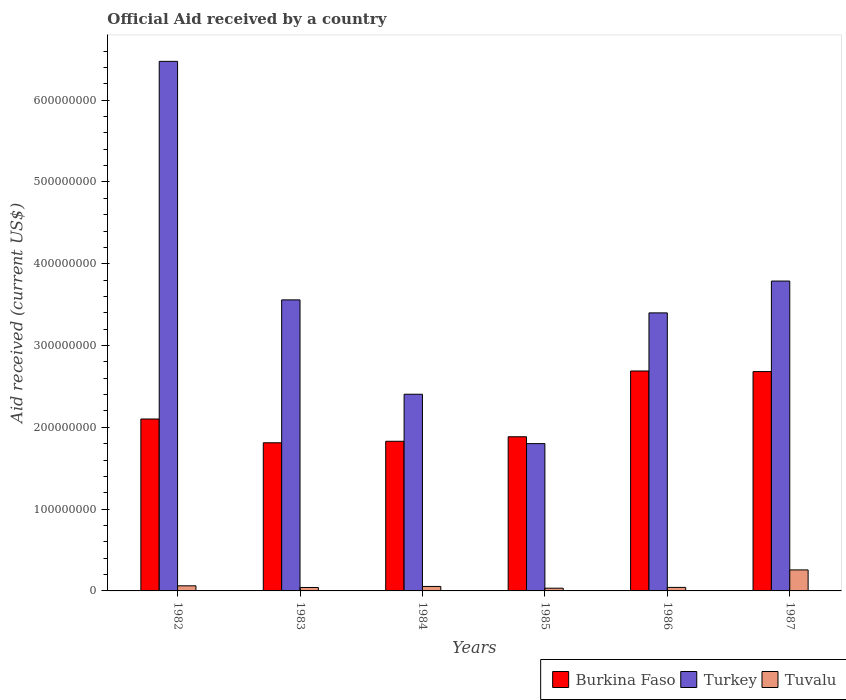How many groups of bars are there?
Offer a terse response. 6. Are the number of bars per tick equal to the number of legend labels?
Ensure brevity in your answer.  Yes. Are the number of bars on each tick of the X-axis equal?
Keep it short and to the point. Yes. How many bars are there on the 6th tick from the left?
Offer a very short reply. 3. How many bars are there on the 6th tick from the right?
Your response must be concise. 3. In how many cases, is the number of bars for a given year not equal to the number of legend labels?
Ensure brevity in your answer.  0. What is the net official aid received in Turkey in 1985?
Provide a succinct answer. 1.80e+08. Across all years, what is the maximum net official aid received in Burkina Faso?
Your answer should be compact. 2.69e+08. Across all years, what is the minimum net official aid received in Turkey?
Ensure brevity in your answer.  1.80e+08. In which year was the net official aid received in Turkey maximum?
Offer a very short reply. 1982. In which year was the net official aid received in Burkina Faso minimum?
Provide a short and direct response. 1983. What is the total net official aid received in Burkina Faso in the graph?
Your answer should be compact. 1.30e+09. What is the difference between the net official aid received in Tuvalu in 1984 and that in 1986?
Offer a very short reply. 1.17e+06. What is the difference between the net official aid received in Burkina Faso in 1982 and the net official aid received in Turkey in 1984?
Your answer should be very brief. -3.03e+07. What is the average net official aid received in Burkina Faso per year?
Provide a succinct answer. 2.17e+08. In the year 1982, what is the difference between the net official aid received in Turkey and net official aid received in Burkina Faso?
Ensure brevity in your answer.  4.37e+08. What is the ratio of the net official aid received in Turkey in 1982 to that in 1985?
Provide a short and direct response. 3.6. Is the difference between the net official aid received in Turkey in 1982 and 1986 greater than the difference between the net official aid received in Burkina Faso in 1982 and 1986?
Keep it short and to the point. Yes. What is the difference between the highest and the second highest net official aid received in Tuvalu?
Give a very brief answer. 1.94e+07. What is the difference between the highest and the lowest net official aid received in Tuvalu?
Ensure brevity in your answer.  2.24e+07. What does the 1st bar from the right in 1984 represents?
Ensure brevity in your answer.  Tuvalu. Is it the case that in every year, the sum of the net official aid received in Burkina Faso and net official aid received in Tuvalu is greater than the net official aid received in Turkey?
Your response must be concise. No. How many years are there in the graph?
Ensure brevity in your answer.  6. Are the values on the major ticks of Y-axis written in scientific E-notation?
Give a very brief answer. No. How many legend labels are there?
Your answer should be very brief. 3. What is the title of the graph?
Provide a short and direct response. Official Aid received by a country. What is the label or title of the Y-axis?
Provide a succinct answer. Aid received (current US$). What is the Aid received (current US$) of Burkina Faso in 1982?
Offer a terse response. 2.10e+08. What is the Aid received (current US$) in Turkey in 1982?
Offer a terse response. 6.48e+08. What is the Aid received (current US$) of Tuvalu in 1982?
Offer a terse response. 6.23e+06. What is the Aid received (current US$) in Burkina Faso in 1983?
Keep it short and to the point. 1.81e+08. What is the Aid received (current US$) of Turkey in 1983?
Provide a short and direct response. 3.56e+08. What is the Aid received (current US$) in Tuvalu in 1983?
Offer a terse response. 4.21e+06. What is the Aid received (current US$) of Burkina Faso in 1984?
Provide a succinct answer. 1.83e+08. What is the Aid received (current US$) in Turkey in 1984?
Keep it short and to the point. 2.40e+08. What is the Aid received (current US$) in Tuvalu in 1984?
Offer a very short reply. 5.47e+06. What is the Aid received (current US$) in Burkina Faso in 1985?
Your answer should be very brief. 1.88e+08. What is the Aid received (current US$) in Turkey in 1985?
Your answer should be compact. 1.80e+08. What is the Aid received (current US$) in Tuvalu in 1985?
Provide a short and direct response. 3.33e+06. What is the Aid received (current US$) of Burkina Faso in 1986?
Make the answer very short. 2.69e+08. What is the Aid received (current US$) of Turkey in 1986?
Your answer should be very brief. 3.40e+08. What is the Aid received (current US$) of Tuvalu in 1986?
Provide a short and direct response. 4.30e+06. What is the Aid received (current US$) in Burkina Faso in 1987?
Your answer should be very brief. 2.68e+08. What is the Aid received (current US$) in Turkey in 1987?
Your response must be concise. 3.79e+08. What is the Aid received (current US$) of Tuvalu in 1987?
Your answer should be compact. 2.57e+07. Across all years, what is the maximum Aid received (current US$) in Burkina Faso?
Provide a short and direct response. 2.69e+08. Across all years, what is the maximum Aid received (current US$) of Turkey?
Your answer should be very brief. 6.48e+08. Across all years, what is the maximum Aid received (current US$) of Tuvalu?
Your answer should be very brief. 2.57e+07. Across all years, what is the minimum Aid received (current US$) in Burkina Faso?
Provide a short and direct response. 1.81e+08. Across all years, what is the minimum Aid received (current US$) in Turkey?
Give a very brief answer. 1.80e+08. Across all years, what is the minimum Aid received (current US$) of Tuvalu?
Make the answer very short. 3.33e+06. What is the total Aid received (current US$) of Burkina Faso in the graph?
Your response must be concise. 1.30e+09. What is the total Aid received (current US$) in Turkey in the graph?
Offer a terse response. 2.14e+09. What is the total Aid received (current US$) of Tuvalu in the graph?
Your response must be concise. 4.92e+07. What is the difference between the Aid received (current US$) of Burkina Faso in 1982 and that in 1983?
Keep it short and to the point. 2.90e+07. What is the difference between the Aid received (current US$) in Turkey in 1982 and that in 1983?
Your response must be concise. 2.92e+08. What is the difference between the Aid received (current US$) in Tuvalu in 1982 and that in 1983?
Provide a short and direct response. 2.02e+06. What is the difference between the Aid received (current US$) of Burkina Faso in 1982 and that in 1984?
Provide a short and direct response. 2.72e+07. What is the difference between the Aid received (current US$) of Turkey in 1982 and that in 1984?
Give a very brief answer. 4.07e+08. What is the difference between the Aid received (current US$) in Tuvalu in 1982 and that in 1984?
Provide a succinct answer. 7.60e+05. What is the difference between the Aid received (current US$) in Burkina Faso in 1982 and that in 1985?
Keep it short and to the point. 2.17e+07. What is the difference between the Aid received (current US$) in Turkey in 1982 and that in 1985?
Make the answer very short. 4.67e+08. What is the difference between the Aid received (current US$) of Tuvalu in 1982 and that in 1985?
Keep it short and to the point. 2.90e+06. What is the difference between the Aid received (current US$) in Burkina Faso in 1982 and that in 1986?
Your answer should be compact. -5.87e+07. What is the difference between the Aid received (current US$) of Turkey in 1982 and that in 1986?
Your response must be concise. 3.08e+08. What is the difference between the Aid received (current US$) of Tuvalu in 1982 and that in 1986?
Ensure brevity in your answer.  1.93e+06. What is the difference between the Aid received (current US$) of Burkina Faso in 1982 and that in 1987?
Your answer should be compact. -5.80e+07. What is the difference between the Aid received (current US$) in Turkey in 1982 and that in 1987?
Your answer should be compact. 2.69e+08. What is the difference between the Aid received (current US$) in Tuvalu in 1982 and that in 1987?
Provide a short and direct response. -1.94e+07. What is the difference between the Aid received (current US$) of Burkina Faso in 1983 and that in 1984?
Your answer should be very brief. -1.84e+06. What is the difference between the Aid received (current US$) in Turkey in 1983 and that in 1984?
Make the answer very short. 1.15e+08. What is the difference between the Aid received (current US$) of Tuvalu in 1983 and that in 1984?
Give a very brief answer. -1.26e+06. What is the difference between the Aid received (current US$) in Burkina Faso in 1983 and that in 1985?
Offer a terse response. -7.35e+06. What is the difference between the Aid received (current US$) of Turkey in 1983 and that in 1985?
Keep it short and to the point. 1.76e+08. What is the difference between the Aid received (current US$) of Tuvalu in 1983 and that in 1985?
Ensure brevity in your answer.  8.80e+05. What is the difference between the Aid received (current US$) of Burkina Faso in 1983 and that in 1986?
Your response must be concise. -8.78e+07. What is the difference between the Aid received (current US$) of Turkey in 1983 and that in 1986?
Your response must be concise. 1.59e+07. What is the difference between the Aid received (current US$) in Tuvalu in 1983 and that in 1986?
Make the answer very short. -9.00e+04. What is the difference between the Aid received (current US$) of Burkina Faso in 1983 and that in 1987?
Give a very brief answer. -8.70e+07. What is the difference between the Aid received (current US$) in Turkey in 1983 and that in 1987?
Keep it short and to the point. -2.30e+07. What is the difference between the Aid received (current US$) of Tuvalu in 1983 and that in 1987?
Your answer should be compact. -2.15e+07. What is the difference between the Aid received (current US$) of Burkina Faso in 1984 and that in 1985?
Offer a terse response. -5.51e+06. What is the difference between the Aid received (current US$) in Turkey in 1984 and that in 1985?
Offer a terse response. 6.04e+07. What is the difference between the Aid received (current US$) in Tuvalu in 1984 and that in 1985?
Offer a very short reply. 2.14e+06. What is the difference between the Aid received (current US$) in Burkina Faso in 1984 and that in 1986?
Provide a short and direct response. -8.59e+07. What is the difference between the Aid received (current US$) in Turkey in 1984 and that in 1986?
Offer a terse response. -9.95e+07. What is the difference between the Aid received (current US$) of Tuvalu in 1984 and that in 1986?
Provide a short and direct response. 1.17e+06. What is the difference between the Aid received (current US$) of Burkina Faso in 1984 and that in 1987?
Offer a very short reply. -8.52e+07. What is the difference between the Aid received (current US$) in Turkey in 1984 and that in 1987?
Provide a short and direct response. -1.38e+08. What is the difference between the Aid received (current US$) in Tuvalu in 1984 and that in 1987?
Make the answer very short. -2.02e+07. What is the difference between the Aid received (current US$) in Burkina Faso in 1985 and that in 1986?
Offer a very short reply. -8.04e+07. What is the difference between the Aid received (current US$) of Turkey in 1985 and that in 1986?
Give a very brief answer. -1.60e+08. What is the difference between the Aid received (current US$) of Tuvalu in 1985 and that in 1986?
Ensure brevity in your answer.  -9.70e+05. What is the difference between the Aid received (current US$) in Burkina Faso in 1985 and that in 1987?
Your response must be concise. -7.97e+07. What is the difference between the Aid received (current US$) in Turkey in 1985 and that in 1987?
Your response must be concise. -1.99e+08. What is the difference between the Aid received (current US$) in Tuvalu in 1985 and that in 1987?
Your response must be concise. -2.24e+07. What is the difference between the Aid received (current US$) of Burkina Faso in 1986 and that in 1987?
Offer a very short reply. 7.30e+05. What is the difference between the Aid received (current US$) in Turkey in 1986 and that in 1987?
Provide a short and direct response. -3.89e+07. What is the difference between the Aid received (current US$) in Tuvalu in 1986 and that in 1987?
Your response must be concise. -2.14e+07. What is the difference between the Aid received (current US$) in Burkina Faso in 1982 and the Aid received (current US$) in Turkey in 1983?
Make the answer very short. -1.46e+08. What is the difference between the Aid received (current US$) of Burkina Faso in 1982 and the Aid received (current US$) of Tuvalu in 1983?
Provide a short and direct response. 2.06e+08. What is the difference between the Aid received (current US$) in Turkey in 1982 and the Aid received (current US$) in Tuvalu in 1983?
Provide a short and direct response. 6.43e+08. What is the difference between the Aid received (current US$) in Burkina Faso in 1982 and the Aid received (current US$) in Turkey in 1984?
Ensure brevity in your answer.  -3.03e+07. What is the difference between the Aid received (current US$) in Burkina Faso in 1982 and the Aid received (current US$) in Tuvalu in 1984?
Ensure brevity in your answer.  2.05e+08. What is the difference between the Aid received (current US$) in Turkey in 1982 and the Aid received (current US$) in Tuvalu in 1984?
Offer a very short reply. 6.42e+08. What is the difference between the Aid received (current US$) in Burkina Faso in 1982 and the Aid received (current US$) in Turkey in 1985?
Keep it short and to the point. 3.01e+07. What is the difference between the Aid received (current US$) of Burkina Faso in 1982 and the Aid received (current US$) of Tuvalu in 1985?
Your answer should be compact. 2.07e+08. What is the difference between the Aid received (current US$) of Turkey in 1982 and the Aid received (current US$) of Tuvalu in 1985?
Ensure brevity in your answer.  6.44e+08. What is the difference between the Aid received (current US$) in Burkina Faso in 1982 and the Aid received (current US$) in Turkey in 1986?
Keep it short and to the point. -1.30e+08. What is the difference between the Aid received (current US$) in Burkina Faso in 1982 and the Aid received (current US$) in Tuvalu in 1986?
Ensure brevity in your answer.  2.06e+08. What is the difference between the Aid received (current US$) of Turkey in 1982 and the Aid received (current US$) of Tuvalu in 1986?
Your response must be concise. 6.43e+08. What is the difference between the Aid received (current US$) in Burkina Faso in 1982 and the Aid received (current US$) in Turkey in 1987?
Your answer should be compact. -1.69e+08. What is the difference between the Aid received (current US$) in Burkina Faso in 1982 and the Aid received (current US$) in Tuvalu in 1987?
Provide a short and direct response. 1.85e+08. What is the difference between the Aid received (current US$) of Turkey in 1982 and the Aid received (current US$) of Tuvalu in 1987?
Keep it short and to the point. 6.22e+08. What is the difference between the Aid received (current US$) in Burkina Faso in 1983 and the Aid received (current US$) in Turkey in 1984?
Your response must be concise. -5.93e+07. What is the difference between the Aid received (current US$) in Burkina Faso in 1983 and the Aid received (current US$) in Tuvalu in 1984?
Give a very brief answer. 1.76e+08. What is the difference between the Aid received (current US$) in Turkey in 1983 and the Aid received (current US$) in Tuvalu in 1984?
Your answer should be compact. 3.50e+08. What is the difference between the Aid received (current US$) of Burkina Faso in 1983 and the Aid received (current US$) of Turkey in 1985?
Make the answer very short. 1.04e+06. What is the difference between the Aid received (current US$) in Burkina Faso in 1983 and the Aid received (current US$) in Tuvalu in 1985?
Make the answer very short. 1.78e+08. What is the difference between the Aid received (current US$) of Turkey in 1983 and the Aid received (current US$) of Tuvalu in 1985?
Your answer should be compact. 3.53e+08. What is the difference between the Aid received (current US$) of Burkina Faso in 1983 and the Aid received (current US$) of Turkey in 1986?
Give a very brief answer. -1.59e+08. What is the difference between the Aid received (current US$) of Burkina Faso in 1983 and the Aid received (current US$) of Tuvalu in 1986?
Make the answer very short. 1.77e+08. What is the difference between the Aid received (current US$) of Turkey in 1983 and the Aid received (current US$) of Tuvalu in 1986?
Make the answer very short. 3.52e+08. What is the difference between the Aid received (current US$) of Burkina Faso in 1983 and the Aid received (current US$) of Turkey in 1987?
Your answer should be compact. -1.98e+08. What is the difference between the Aid received (current US$) of Burkina Faso in 1983 and the Aid received (current US$) of Tuvalu in 1987?
Offer a very short reply. 1.55e+08. What is the difference between the Aid received (current US$) of Turkey in 1983 and the Aid received (current US$) of Tuvalu in 1987?
Offer a terse response. 3.30e+08. What is the difference between the Aid received (current US$) of Burkina Faso in 1984 and the Aid received (current US$) of Turkey in 1985?
Offer a very short reply. 2.88e+06. What is the difference between the Aid received (current US$) of Burkina Faso in 1984 and the Aid received (current US$) of Tuvalu in 1985?
Your response must be concise. 1.80e+08. What is the difference between the Aid received (current US$) in Turkey in 1984 and the Aid received (current US$) in Tuvalu in 1985?
Give a very brief answer. 2.37e+08. What is the difference between the Aid received (current US$) of Burkina Faso in 1984 and the Aid received (current US$) of Turkey in 1986?
Your answer should be compact. -1.57e+08. What is the difference between the Aid received (current US$) of Burkina Faso in 1984 and the Aid received (current US$) of Tuvalu in 1986?
Give a very brief answer. 1.79e+08. What is the difference between the Aid received (current US$) in Turkey in 1984 and the Aid received (current US$) in Tuvalu in 1986?
Your response must be concise. 2.36e+08. What is the difference between the Aid received (current US$) in Burkina Faso in 1984 and the Aid received (current US$) in Turkey in 1987?
Ensure brevity in your answer.  -1.96e+08. What is the difference between the Aid received (current US$) in Burkina Faso in 1984 and the Aid received (current US$) in Tuvalu in 1987?
Keep it short and to the point. 1.57e+08. What is the difference between the Aid received (current US$) in Turkey in 1984 and the Aid received (current US$) in Tuvalu in 1987?
Your answer should be compact. 2.15e+08. What is the difference between the Aid received (current US$) of Burkina Faso in 1985 and the Aid received (current US$) of Turkey in 1986?
Your answer should be very brief. -1.51e+08. What is the difference between the Aid received (current US$) of Burkina Faso in 1985 and the Aid received (current US$) of Tuvalu in 1986?
Offer a very short reply. 1.84e+08. What is the difference between the Aid received (current US$) of Turkey in 1985 and the Aid received (current US$) of Tuvalu in 1986?
Offer a terse response. 1.76e+08. What is the difference between the Aid received (current US$) in Burkina Faso in 1985 and the Aid received (current US$) in Turkey in 1987?
Give a very brief answer. -1.90e+08. What is the difference between the Aid received (current US$) in Burkina Faso in 1985 and the Aid received (current US$) in Tuvalu in 1987?
Make the answer very short. 1.63e+08. What is the difference between the Aid received (current US$) in Turkey in 1985 and the Aid received (current US$) in Tuvalu in 1987?
Offer a terse response. 1.54e+08. What is the difference between the Aid received (current US$) in Burkina Faso in 1986 and the Aid received (current US$) in Turkey in 1987?
Keep it short and to the point. -1.10e+08. What is the difference between the Aid received (current US$) of Burkina Faso in 1986 and the Aid received (current US$) of Tuvalu in 1987?
Keep it short and to the point. 2.43e+08. What is the difference between the Aid received (current US$) of Turkey in 1986 and the Aid received (current US$) of Tuvalu in 1987?
Give a very brief answer. 3.14e+08. What is the average Aid received (current US$) of Burkina Faso per year?
Provide a short and direct response. 2.17e+08. What is the average Aid received (current US$) in Turkey per year?
Keep it short and to the point. 3.57e+08. What is the average Aid received (current US$) of Tuvalu per year?
Provide a short and direct response. 8.20e+06. In the year 1982, what is the difference between the Aid received (current US$) of Burkina Faso and Aid received (current US$) of Turkey?
Give a very brief answer. -4.37e+08. In the year 1982, what is the difference between the Aid received (current US$) of Burkina Faso and Aid received (current US$) of Tuvalu?
Your answer should be very brief. 2.04e+08. In the year 1982, what is the difference between the Aid received (current US$) in Turkey and Aid received (current US$) in Tuvalu?
Offer a very short reply. 6.41e+08. In the year 1983, what is the difference between the Aid received (current US$) in Burkina Faso and Aid received (current US$) in Turkey?
Make the answer very short. -1.75e+08. In the year 1983, what is the difference between the Aid received (current US$) of Burkina Faso and Aid received (current US$) of Tuvalu?
Make the answer very short. 1.77e+08. In the year 1983, what is the difference between the Aid received (current US$) in Turkey and Aid received (current US$) in Tuvalu?
Offer a terse response. 3.52e+08. In the year 1984, what is the difference between the Aid received (current US$) of Burkina Faso and Aid received (current US$) of Turkey?
Your response must be concise. -5.75e+07. In the year 1984, what is the difference between the Aid received (current US$) of Burkina Faso and Aid received (current US$) of Tuvalu?
Offer a very short reply. 1.78e+08. In the year 1984, what is the difference between the Aid received (current US$) of Turkey and Aid received (current US$) of Tuvalu?
Provide a succinct answer. 2.35e+08. In the year 1985, what is the difference between the Aid received (current US$) in Burkina Faso and Aid received (current US$) in Turkey?
Your answer should be compact. 8.39e+06. In the year 1985, what is the difference between the Aid received (current US$) in Burkina Faso and Aid received (current US$) in Tuvalu?
Make the answer very short. 1.85e+08. In the year 1985, what is the difference between the Aid received (current US$) of Turkey and Aid received (current US$) of Tuvalu?
Your answer should be very brief. 1.77e+08. In the year 1986, what is the difference between the Aid received (current US$) of Burkina Faso and Aid received (current US$) of Turkey?
Your answer should be compact. -7.10e+07. In the year 1986, what is the difference between the Aid received (current US$) of Burkina Faso and Aid received (current US$) of Tuvalu?
Make the answer very short. 2.65e+08. In the year 1986, what is the difference between the Aid received (current US$) in Turkey and Aid received (current US$) in Tuvalu?
Your answer should be very brief. 3.36e+08. In the year 1987, what is the difference between the Aid received (current US$) of Burkina Faso and Aid received (current US$) of Turkey?
Ensure brevity in your answer.  -1.11e+08. In the year 1987, what is the difference between the Aid received (current US$) of Burkina Faso and Aid received (current US$) of Tuvalu?
Make the answer very short. 2.42e+08. In the year 1987, what is the difference between the Aid received (current US$) of Turkey and Aid received (current US$) of Tuvalu?
Make the answer very short. 3.53e+08. What is the ratio of the Aid received (current US$) of Burkina Faso in 1982 to that in 1983?
Make the answer very short. 1.16. What is the ratio of the Aid received (current US$) of Turkey in 1982 to that in 1983?
Give a very brief answer. 1.82. What is the ratio of the Aid received (current US$) in Tuvalu in 1982 to that in 1983?
Make the answer very short. 1.48. What is the ratio of the Aid received (current US$) of Burkina Faso in 1982 to that in 1984?
Make the answer very short. 1.15. What is the ratio of the Aid received (current US$) in Turkey in 1982 to that in 1984?
Provide a succinct answer. 2.69. What is the ratio of the Aid received (current US$) in Tuvalu in 1982 to that in 1984?
Your answer should be compact. 1.14. What is the ratio of the Aid received (current US$) in Burkina Faso in 1982 to that in 1985?
Keep it short and to the point. 1.12. What is the ratio of the Aid received (current US$) in Turkey in 1982 to that in 1985?
Ensure brevity in your answer.  3.6. What is the ratio of the Aid received (current US$) in Tuvalu in 1982 to that in 1985?
Your answer should be compact. 1.87. What is the ratio of the Aid received (current US$) of Burkina Faso in 1982 to that in 1986?
Give a very brief answer. 0.78. What is the ratio of the Aid received (current US$) of Turkey in 1982 to that in 1986?
Offer a terse response. 1.9. What is the ratio of the Aid received (current US$) in Tuvalu in 1982 to that in 1986?
Keep it short and to the point. 1.45. What is the ratio of the Aid received (current US$) in Burkina Faso in 1982 to that in 1987?
Ensure brevity in your answer.  0.78. What is the ratio of the Aid received (current US$) of Turkey in 1982 to that in 1987?
Your response must be concise. 1.71. What is the ratio of the Aid received (current US$) of Tuvalu in 1982 to that in 1987?
Your answer should be compact. 0.24. What is the ratio of the Aid received (current US$) in Turkey in 1983 to that in 1984?
Keep it short and to the point. 1.48. What is the ratio of the Aid received (current US$) of Tuvalu in 1983 to that in 1984?
Give a very brief answer. 0.77. What is the ratio of the Aid received (current US$) in Burkina Faso in 1983 to that in 1985?
Offer a terse response. 0.96. What is the ratio of the Aid received (current US$) in Turkey in 1983 to that in 1985?
Give a very brief answer. 1.98. What is the ratio of the Aid received (current US$) in Tuvalu in 1983 to that in 1985?
Ensure brevity in your answer.  1.26. What is the ratio of the Aid received (current US$) of Burkina Faso in 1983 to that in 1986?
Ensure brevity in your answer.  0.67. What is the ratio of the Aid received (current US$) in Turkey in 1983 to that in 1986?
Offer a very short reply. 1.05. What is the ratio of the Aid received (current US$) in Tuvalu in 1983 to that in 1986?
Your response must be concise. 0.98. What is the ratio of the Aid received (current US$) in Burkina Faso in 1983 to that in 1987?
Your answer should be very brief. 0.68. What is the ratio of the Aid received (current US$) in Turkey in 1983 to that in 1987?
Your answer should be compact. 0.94. What is the ratio of the Aid received (current US$) of Tuvalu in 1983 to that in 1987?
Offer a very short reply. 0.16. What is the ratio of the Aid received (current US$) in Burkina Faso in 1984 to that in 1985?
Your answer should be very brief. 0.97. What is the ratio of the Aid received (current US$) of Turkey in 1984 to that in 1985?
Keep it short and to the point. 1.34. What is the ratio of the Aid received (current US$) in Tuvalu in 1984 to that in 1985?
Provide a short and direct response. 1.64. What is the ratio of the Aid received (current US$) of Burkina Faso in 1984 to that in 1986?
Give a very brief answer. 0.68. What is the ratio of the Aid received (current US$) in Turkey in 1984 to that in 1986?
Provide a short and direct response. 0.71. What is the ratio of the Aid received (current US$) of Tuvalu in 1984 to that in 1986?
Your response must be concise. 1.27. What is the ratio of the Aid received (current US$) in Burkina Faso in 1984 to that in 1987?
Your answer should be very brief. 0.68. What is the ratio of the Aid received (current US$) in Turkey in 1984 to that in 1987?
Ensure brevity in your answer.  0.63. What is the ratio of the Aid received (current US$) in Tuvalu in 1984 to that in 1987?
Keep it short and to the point. 0.21. What is the ratio of the Aid received (current US$) in Burkina Faso in 1985 to that in 1986?
Keep it short and to the point. 0.7. What is the ratio of the Aid received (current US$) in Turkey in 1985 to that in 1986?
Your response must be concise. 0.53. What is the ratio of the Aid received (current US$) in Tuvalu in 1985 to that in 1986?
Ensure brevity in your answer.  0.77. What is the ratio of the Aid received (current US$) of Burkina Faso in 1985 to that in 1987?
Your answer should be compact. 0.7. What is the ratio of the Aid received (current US$) of Turkey in 1985 to that in 1987?
Give a very brief answer. 0.48. What is the ratio of the Aid received (current US$) in Tuvalu in 1985 to that in 1987?
Your answer should be compact. 0.13. What is the ratio of the Aid received (current US$) of Burkina Faso in 1986 to that in 1987?
Make the answer very short. 1. What is the ratio of the Aid received (current US$) of Turkey in 1986 to that in 1987?
Your response must be concise. 0.9. What is the ratio of the Aid received (current US$) in Tuvalu in 1986 to that in 1987?
Give a very brief answer. 0.17. What is the difference between the highest and the second highest Aid received (current US$) of Burkina Faso?
Make the answer very short. 7.30e+05. What is the difference between the highest and the second highest Aid received (current US$) in Turkey?
Give a very brief answer. 2.69e+08. What is the difference between the highest and the second highest Aid received (current US$) of Tuvalu?
Your answer should be very brief. 1.94e+07. What is the difference between the highest and the lowest Aid received (current US$) in Burkina Faso?
Give a very brief answer. 8.78e+07. What is the difference between the highest and the lowest Aid received (current US$) of Turkey?
Provide a short and direct response. 4.67e+08. What is the difference between the highest and the lowest Aid received (current US$) of Tuvalu?
Provide a short and direct response. 2.24e+07. 